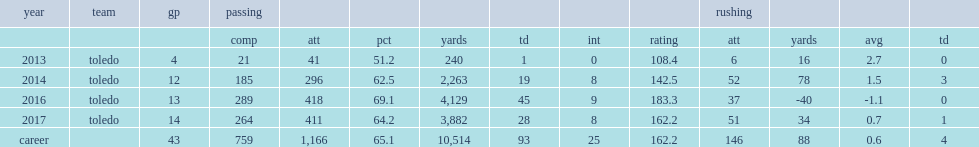At the end of the season, how many yards did logan woodside record with 8 interceptions? 4129.0. At the end of the season, how many touchdowns did logan woodside record with 8 interceptions? 45.0. 